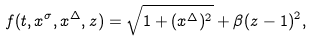<formula> <loc_0><loc_0><loc_500><loc_500>f ( t , x ^ { \sigma } , x ^ { \Delta } , z ) = \sqrt { 1 + ( x ^ { \Delta } ) ^ { 2 } } + \beta ( z - 1 ) ^ { 2 } ,</formula> 